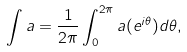<formula> <loc_0><loc_0><loc_500><loc_500>\int a = \frac { 1 } { 2 \pi } \int _ { 0 } ^ { 2 \pi } a ( e ^ { i \theta } ) d \theta ,</formula> 